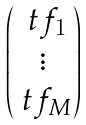Convert formula to latex. <formula><loc_0><loc_0><loc_500><loc_500>\begin{pmatrix} \ t f _ { 1 } \\ \vdots \\ \ t f _ { M } \end{pmatrix}</formula> 